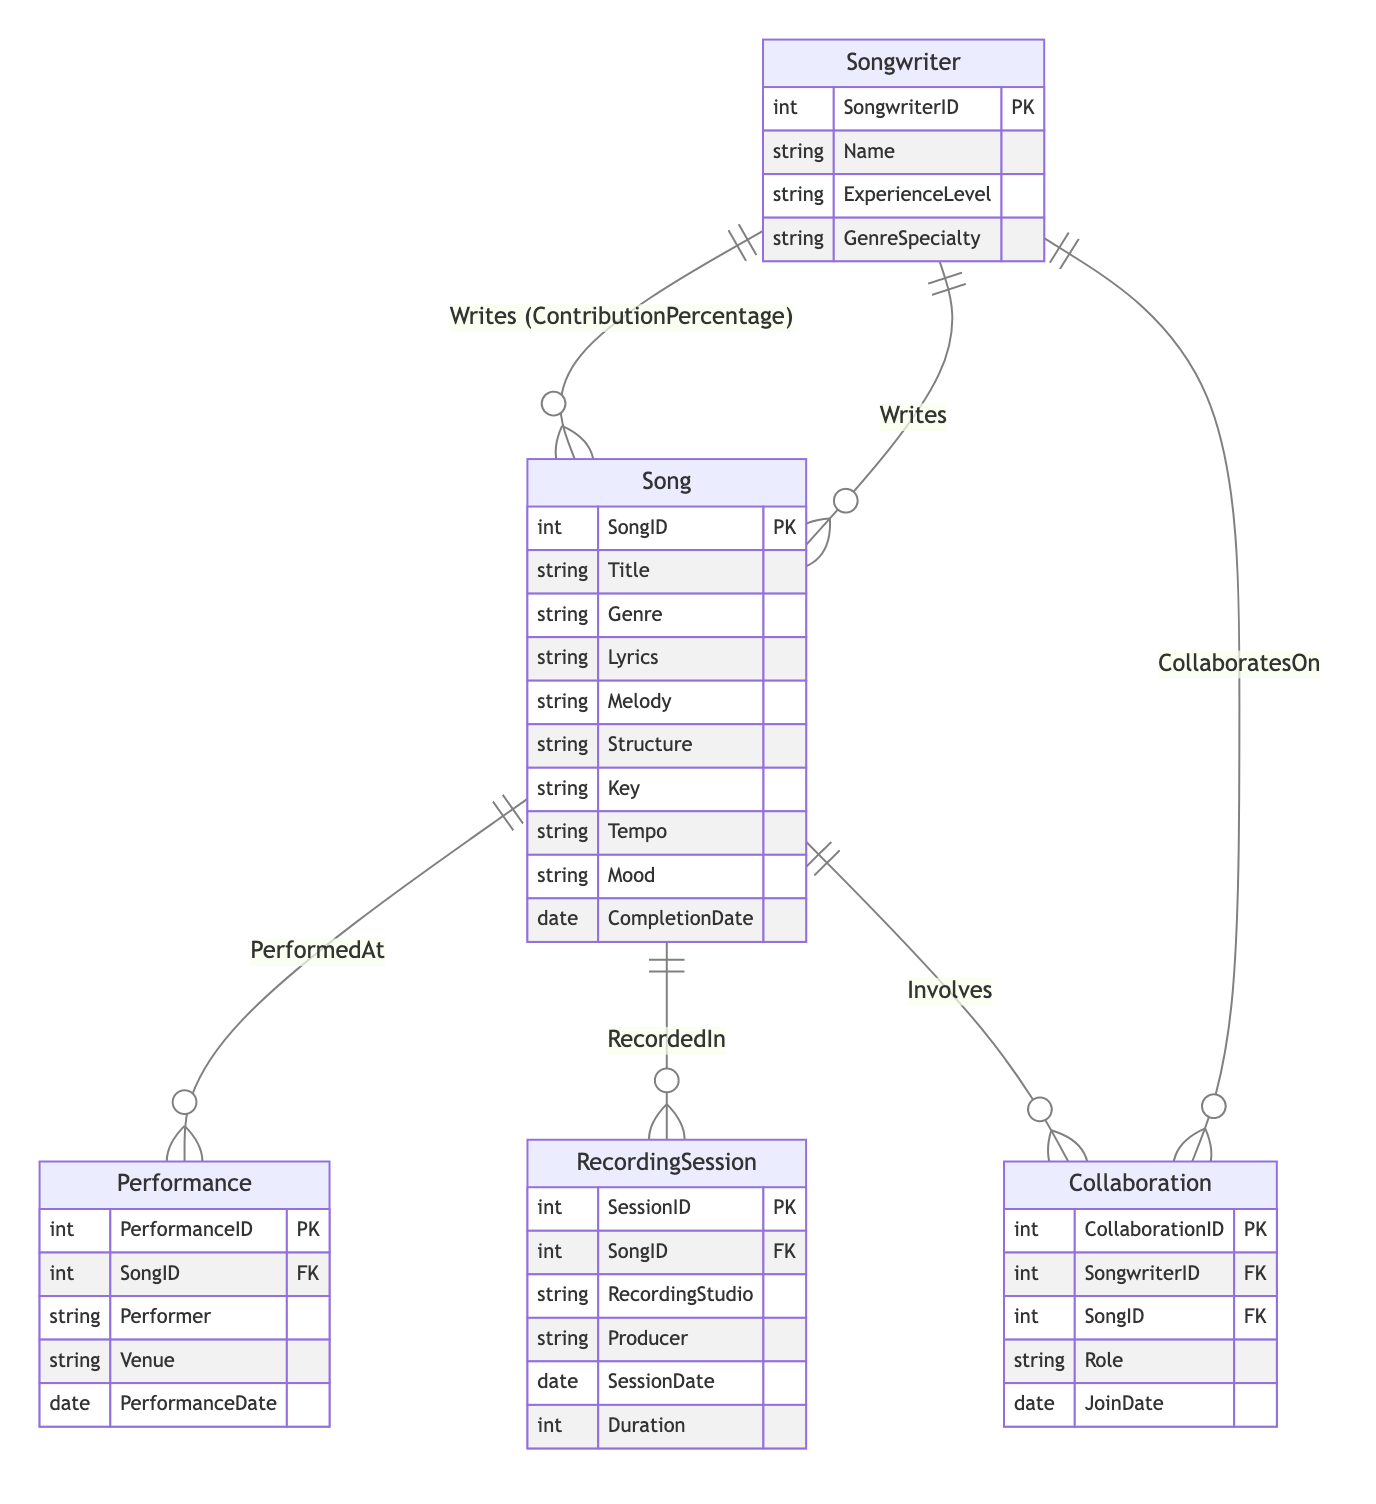What is the primary key of the Songwriter entity? The primary key is the unique identifier for the Songwriter entity, which is labeled as "SongwriterID" in the diagram.
Answer: SongwriterID How many attributes does the Song entity have? The Song entity includes the following attributes: Title, Genre, Lyrics, Melody, Structure, Key, Tempo, Mood, and CompletionDate, making a total of 9 attributes.
Answer: 9 What relationship exists between the Songwriter and Collaboration entities? The diagram shows that the Songwriter collaborates on collaborations, represented as "CollaboratesOn," indicating a direct relationship between these two entities.
Answer: CollaboratesOn Which entity has a relationship labeled "RecordedIn"? The relationship "RecordedIn" connects the Song entity to the RecordingSession entity, indicating that songs are recorded in these sessions.
Answer: RecordingSession How many primary keys are present in the diagram? The diagram includes 5 entities (Songwriter, Song, Collaboration, RecordingSession, Performance), each having one primary key, thus totaling 5 primary keys.
Answer: 5 What is the role of the Songwriter in the collaboration? The attribute "Role" in the Collaboration entity indicates the specific role that a Songwriter plays in the collaboration process, demonstrating the nature of their involvement.
Answer: Role What is the foreign key in the RecordingSession entity? The RecordingSession entity contains a foreign key, "SongID," which links it to the Song entity, establishing a connection between recorded sessions and their respective songs.
Answer: SongID What is the unique identifier for the Collaboration entity? The unique identifier for the Collaboration entity is "CollaborationID," which serves as its primary key, differentiating each collaboration entry.
Answer: CollaborationID Who performs the song in the Performance entity? The "Performer" attribute in the Performance entity indicates that the performer is the one executing the song in a given performance scenario, highlighting their role.
Answer: Performer 